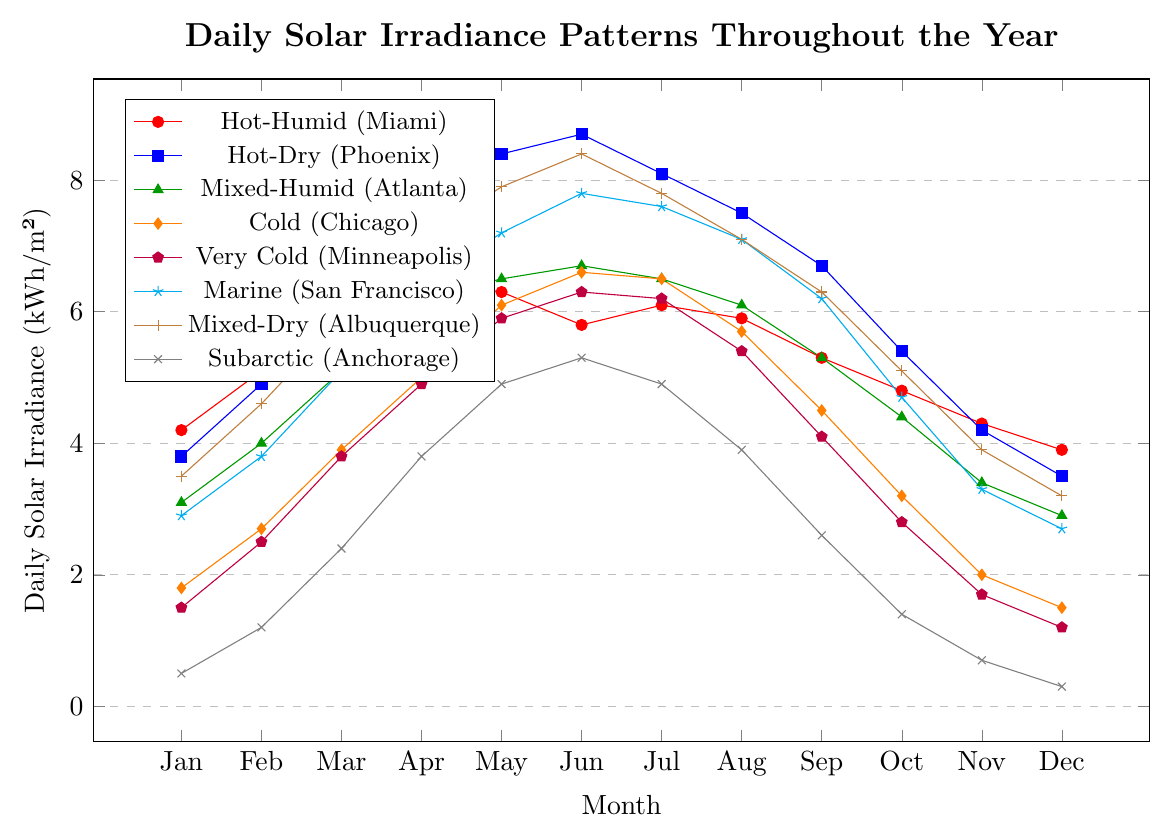How does the daily solar irradiance in Hot-Humid (Miami) during January compare to Marine (San Francisco) during January? By observing the chart, find the data points for January for both Hot-Humid (Miami) and Marine (San Francisco). Compare the values. Miami has an irradiance of 4.2 kWh/m², while San Francisco has 2.9 kWh/m². Therefore, Miami has a higher solar irradiance.
Answer: Miami has higher irradiance Which climate zone has the highest daily solar irradiance in June and what is the value? Identify the highest point on the graph for June. When examining all lines at June, the Hot-Dry (Phoenix) has the peak irradiance of 8.7 kWh/m².
Answer: Phoenix, 8.7 kWh/m² Are there any months where the daily solar irradiance in Subarctic (Anchorage) is higher than in Cold (Chicago)? Compare the values at each month for both Anchorage and Chicago. For all months, Anchorage has lower irradiance values than Chicago. There are no months where Anchorage is higher.
Answer: No What is the average daily solar irradiance in Mixed-Dry (Albuquerque) for April to August? Find the irradiance values for Albuquerque from April to August (7.1, 7.9, 8.4, 7.8, 7.1). Sum these values and divide by the number of months. The average is (7.1+7.9+8.4+7.8+7.1)/5 = 7.66 kWh/m².
Answer: 7.66 kWh/m² Which climate zone shows the least variation in daily solar irradiance throughout the year? To determine this, visually assess the lines' range and consistency. The least variational line will have the smallest difference between its peak and lowest values. Marine (San Francisco) appears to have the least variation, ranging approximately from 2.7 to 7.8 kWh/m².
Answer: Marine (San Francisco) What is the difference in peak solar irradiance between Hot-Dry (Phoenix) and Cold (Chicago)? Find the peak solar irradiance values in the year for both Phoenix (8.7 kWh/m²) and Chicago (6.6 kWh/m²). Subtract Chicago’s peak from Phoenix’s peak (8.7 - 6.6). The difference is 2.1 kWh/m².
Answer: 2.1 kWh/m² During which month does Mixed-Humid (Atlanta) have its highest daily solar irradiance and what is the value? Look at the chart for the peak of the Atlanta line and note the corresponding month and value. The highest value for Atlanta is in June at 6.7 kWh/m².
Answer: June, 6.7 kWh/m² Which month experiences the lowest solar irradiance in Subarctic (Anchorage) and what is the value? Identify the lowest point on the Anchorage line. The lowest value is in December at 0.3 kWh/m².
Answer: December, 0.3 kWh/m² 